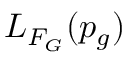Convert formula to latex. <formula><loc_0><loc_0><loc_500><loc_500>L _ { F _ { G } } ( p _ { g } )</formula> 